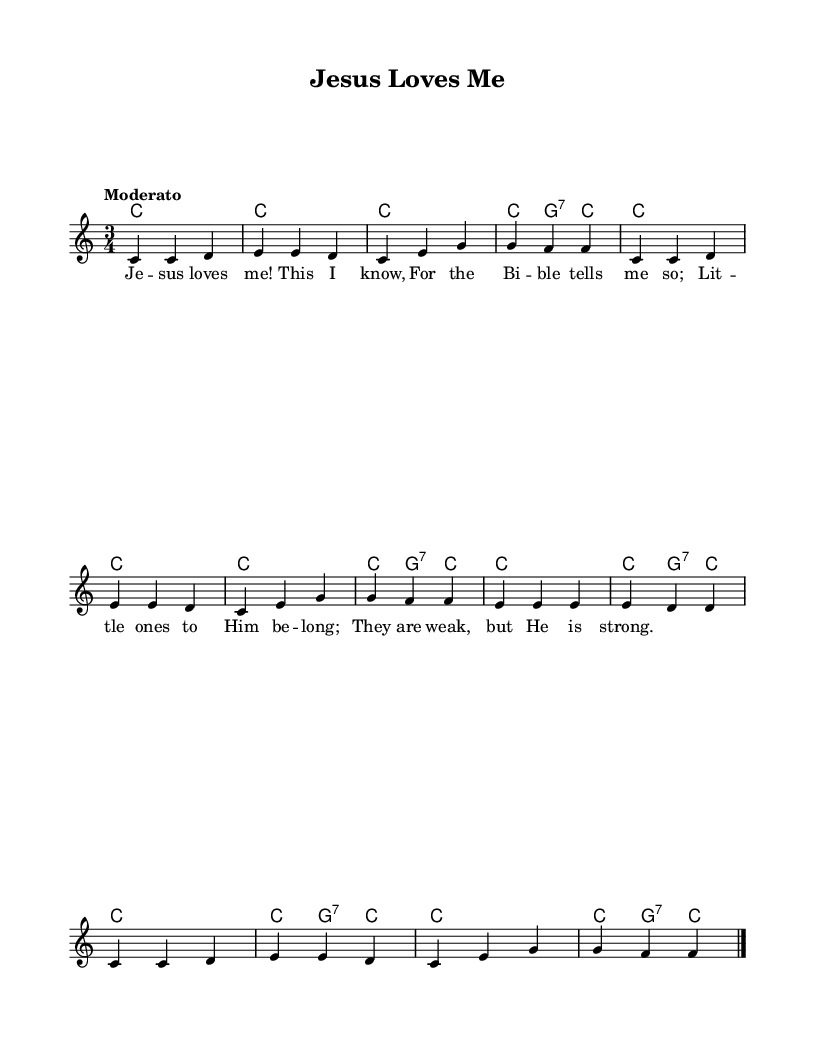What is the key signature of this music? The key signature is C major, which has no sharps or flats.
Answer: C major What is the time signature of this hymn? The time signature shown in the sheet music is 3/4, indicating three beats per measure.
Answer: 3/4 What is the tempo marking for this piece? The tempo marking indicated is "Moderato," which signifies a moderate pace.
Answer: Moderato How many measures are in the melody? By counting the musical phrases in the melody, there are a total of 12 measures.
Answer: 12 What type of chord is used in the second measure? The chord in the second measure is C major, as indicated by the chord names.
Answer: C What is the first lyric line of the hymn? The first line of lyrics states, "Jesus loves me! This I know," which is the opening phrase.
Answer: Jesus loves me! This I know What melodic pattern is repeated in the hymn? The melodic pattern of the first phrase is repeated, generally involving the notes C, D, and E.
Answer: C, D, E 